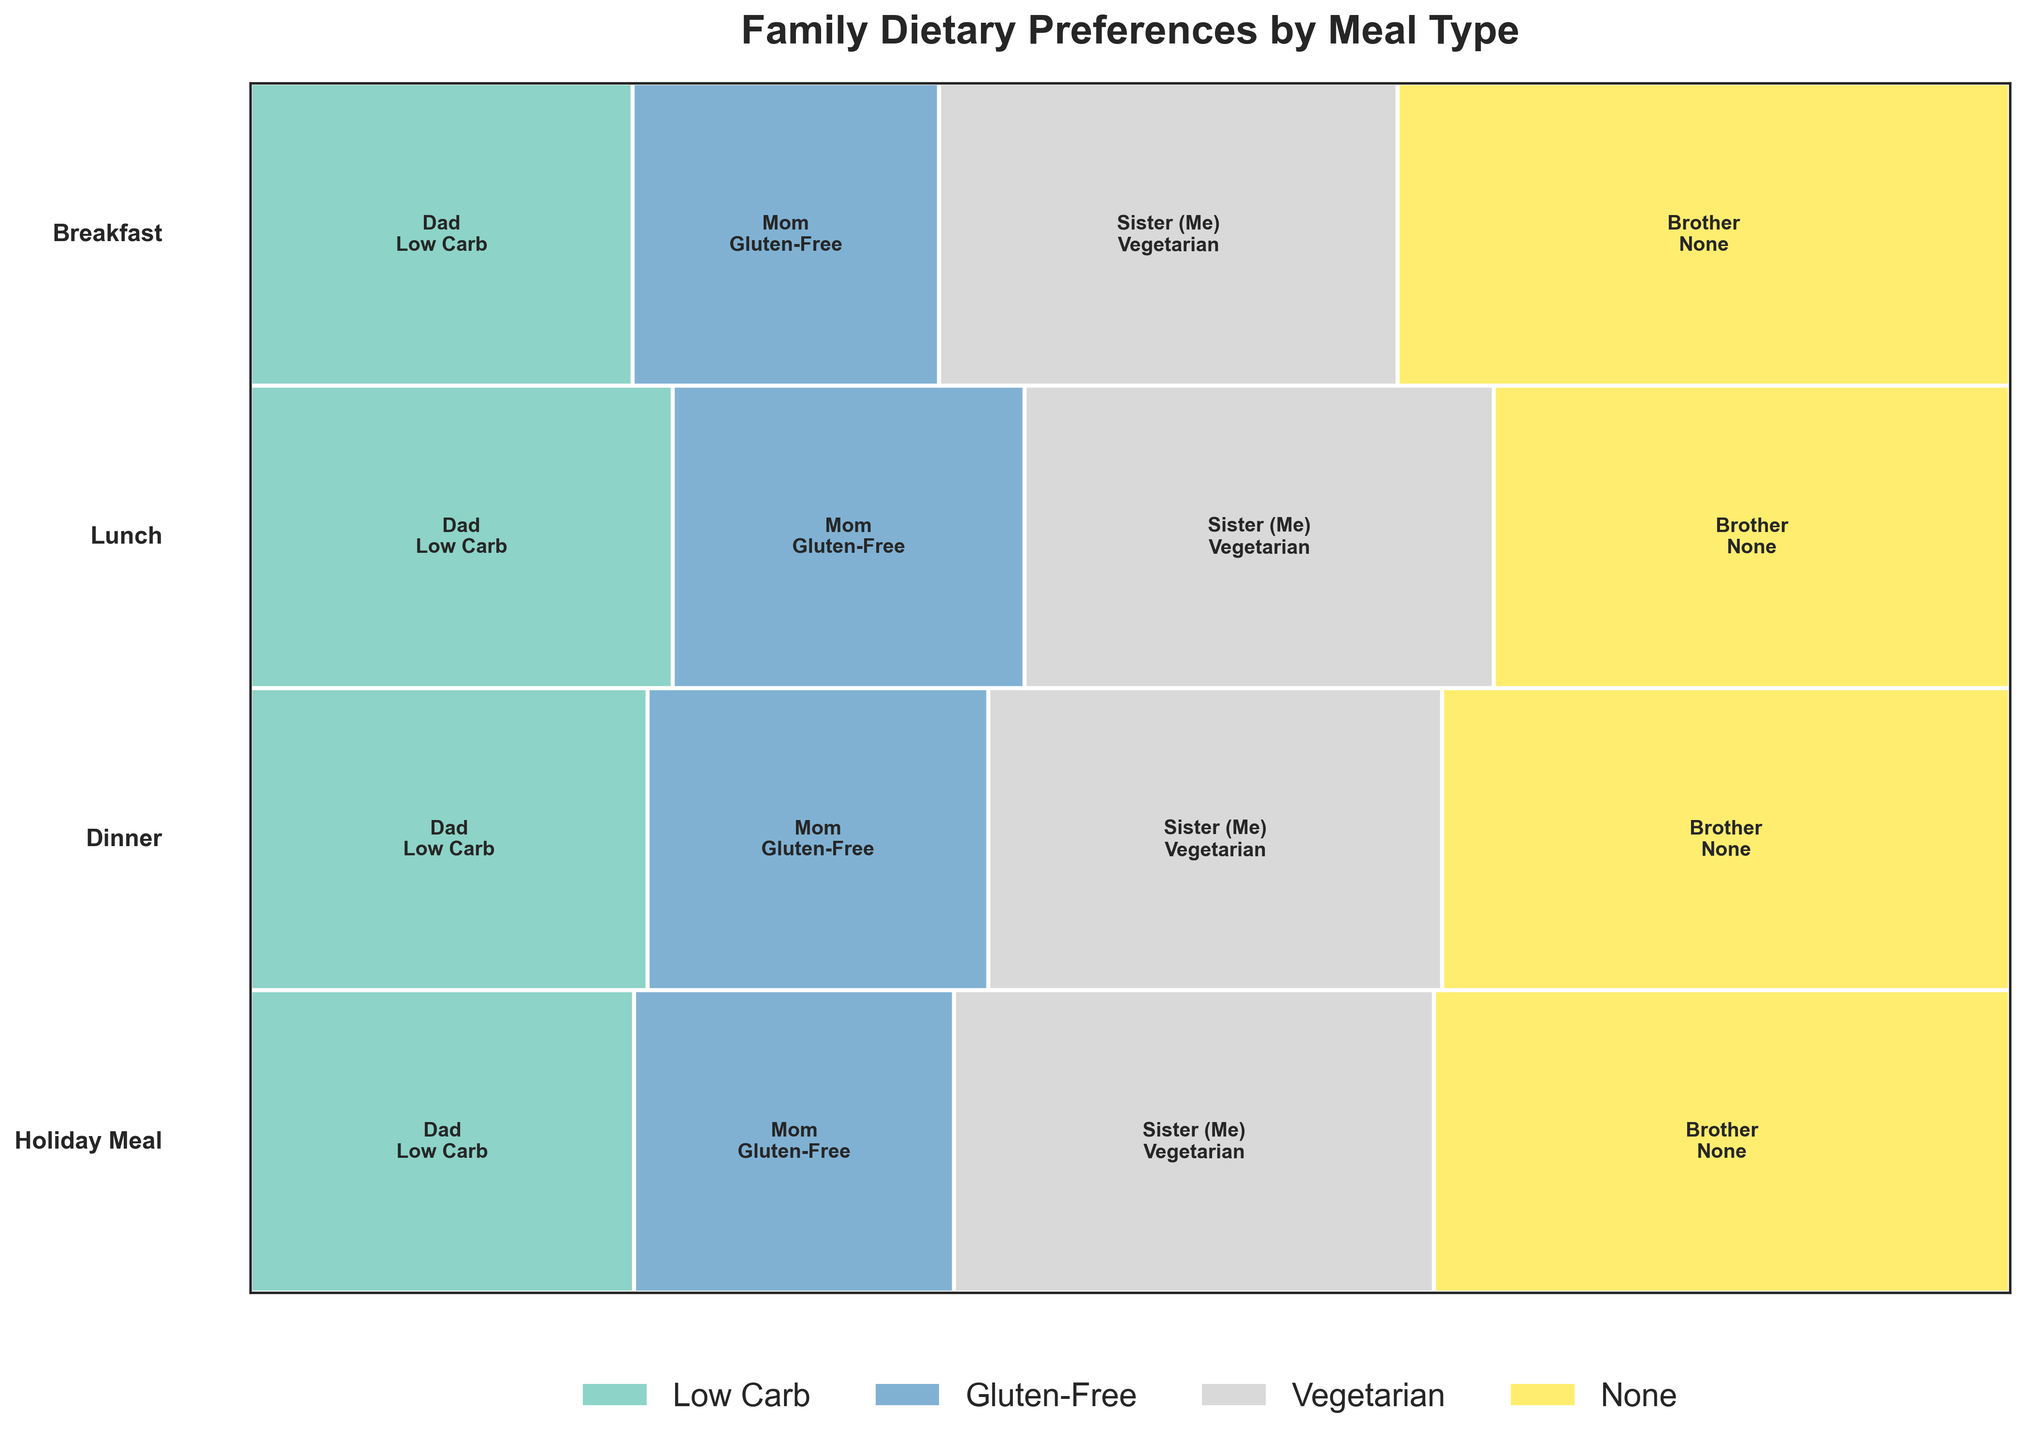What's the title of the Mosaic Plot? The title is displayed prominently at the top of the plot. It summarizes the content of the plot.
Answer: Family Dietary Preferences by Meal Type Which family member has the highest frequency of none dietary requirements during breakfast? Look for the family member whose breakfast bar has the largest proportion colored to represent no dietary requirements (Brother).
Answer: Brother Which meal type shows the highest frequency of dietary preferences for the Dad? Compare the size of the bars representing the Dad's dietary preference across all meal types (Breakfast, Lunch, Dinner, and Holiday Meal) and identify the largest one.
Answer: Dinner How does the Vegetarian preference frequency of the Sister compare between lunch and dinner? Compare the size and proportion of the rectangles for the Sister under 'Vegetarian' for lunch and dinner.
Answer: Dinner is higher Sum the frequencies for all family members' dietary preferences during holiday meals. Add the frequencies for Dad (5), Mom (4), Sister (6), and Brother (8) for holiday meals.
Answer: 23 Which dietary requirement appears most frequently for the Mom? Identify the largest rectangle for Mom across all meals and check its color against the legend for Gluten-Free.
Answer: Gluten-Free Is the proportion of dietary preferences for family members consistent across all meal types or does it vary? Compare the sizes of rectangles for each family member across different meals. Note any differences.
Answer: It varies What are the most frequent dietary preferences for each family member for any given meal type? Identify the largest rectangle or sum of rectangles per meal type for each family member by their color and corresponding dietary requirement.
Answer: Dad: Low Carb, Mom: Gluten-Free, Sister: Vegetarian, Brother: None 